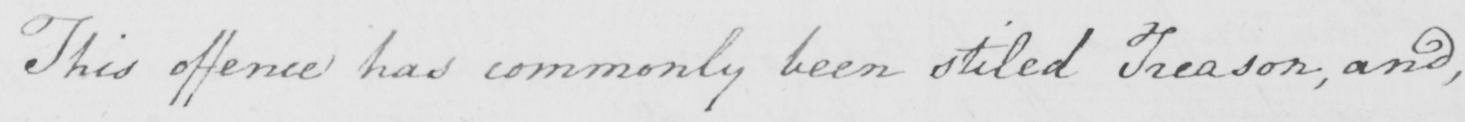Please provide the text content of this handwritten line. This offence has commonly been stiled Treason , and , 